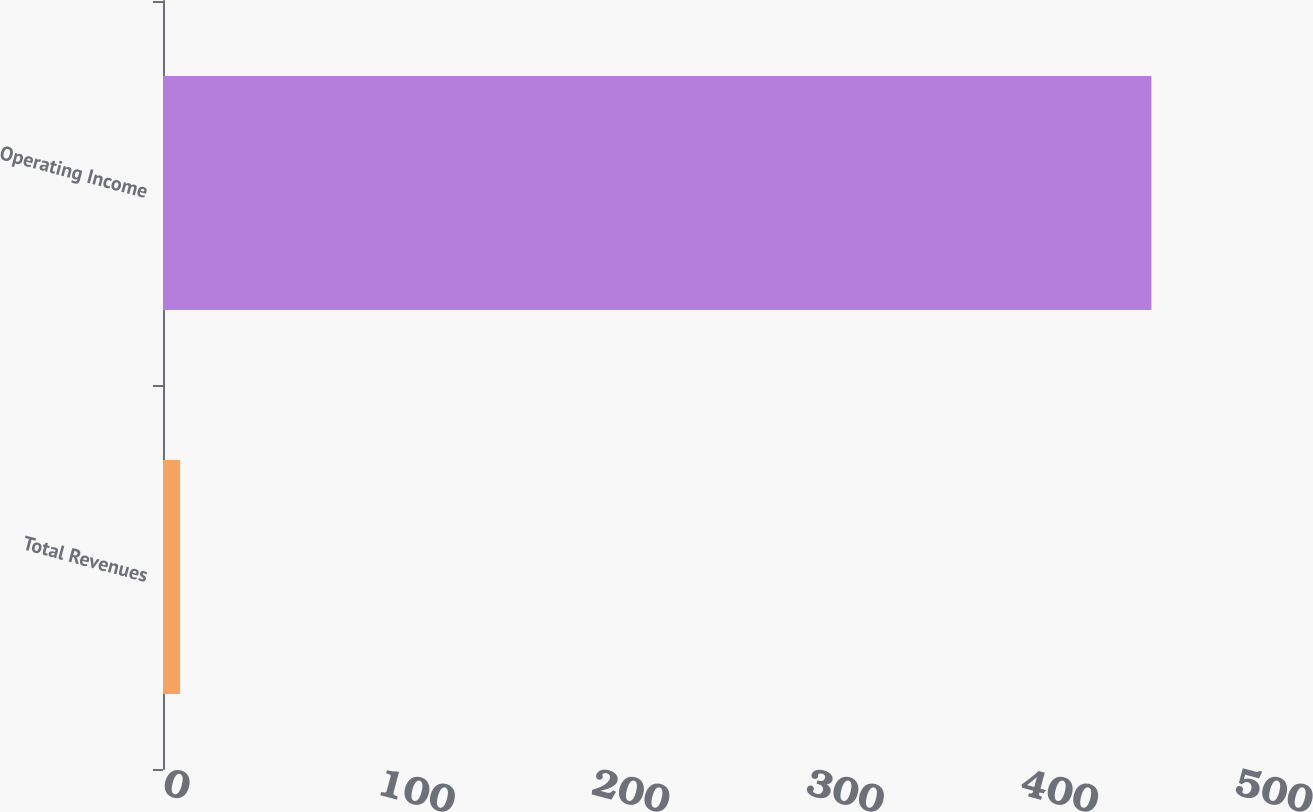Convert chart. <chart><loc_0><loc_0><loc_500><loc_500><bar_chart><fcel>Total Revenues<fcel>Operating Income<nl><fcel>8<fcel>461<nl></chart> 